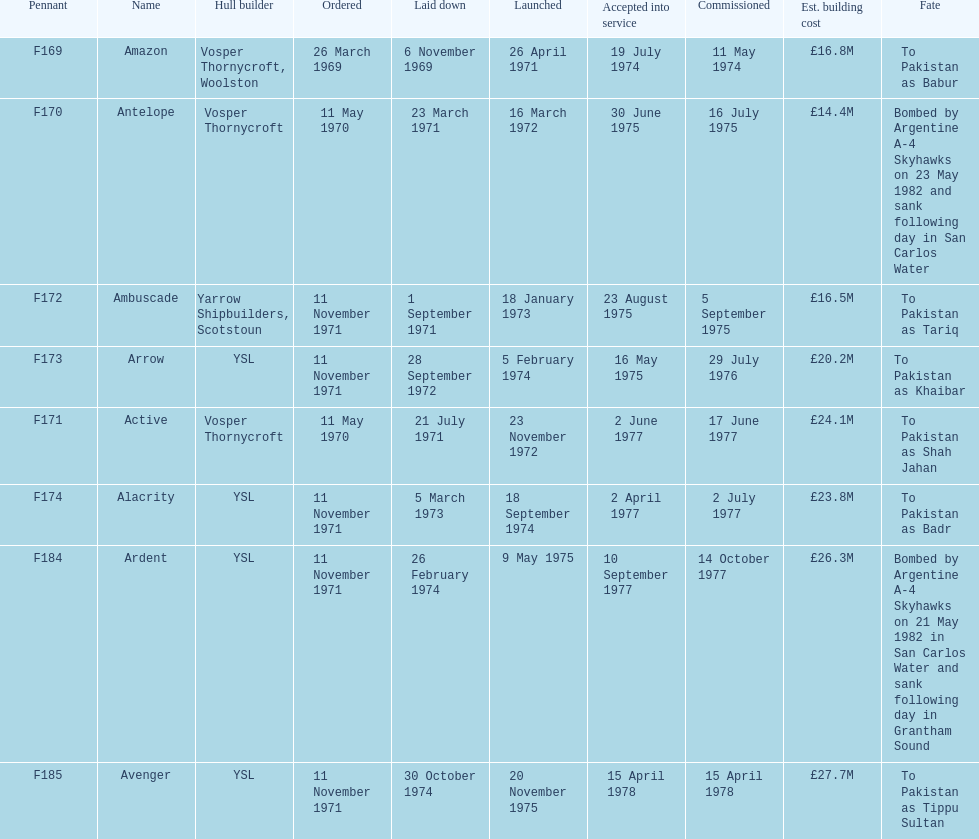Can you provide the name of the ship that is listed after ardent? Avenger. 